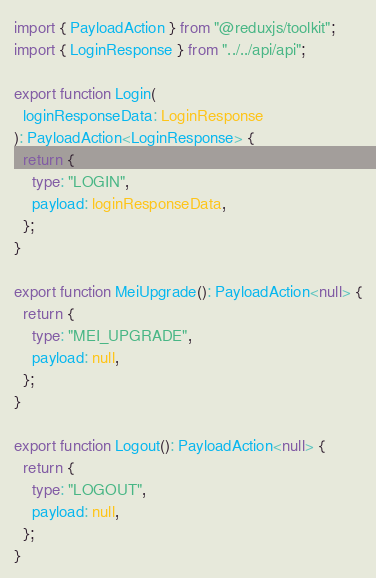Convert code to text. <code><loc_0><loc_0><loc_500><loc_500><_TypeScript_>import { PayloadAction } from "@reduxjs/toolkit";
import { LoginResponse } from "../../api/api";

export function Login(
  loginResponseData: LoginResponse
): PayloadAction<LoginResponse> {
  return {
    type: "LOGIN",
    payload: loginResponseData,
  };
}

export function MeiUpgrade(): PayloadAction<null> {
  return {
    type: "MEI_UPGRADE",
    payload: null,
  };
}

export function Logout(): PayloadAction<null> {
  return {
    type: "LOGOUT",
    payload: null,
  };
}
</code> 